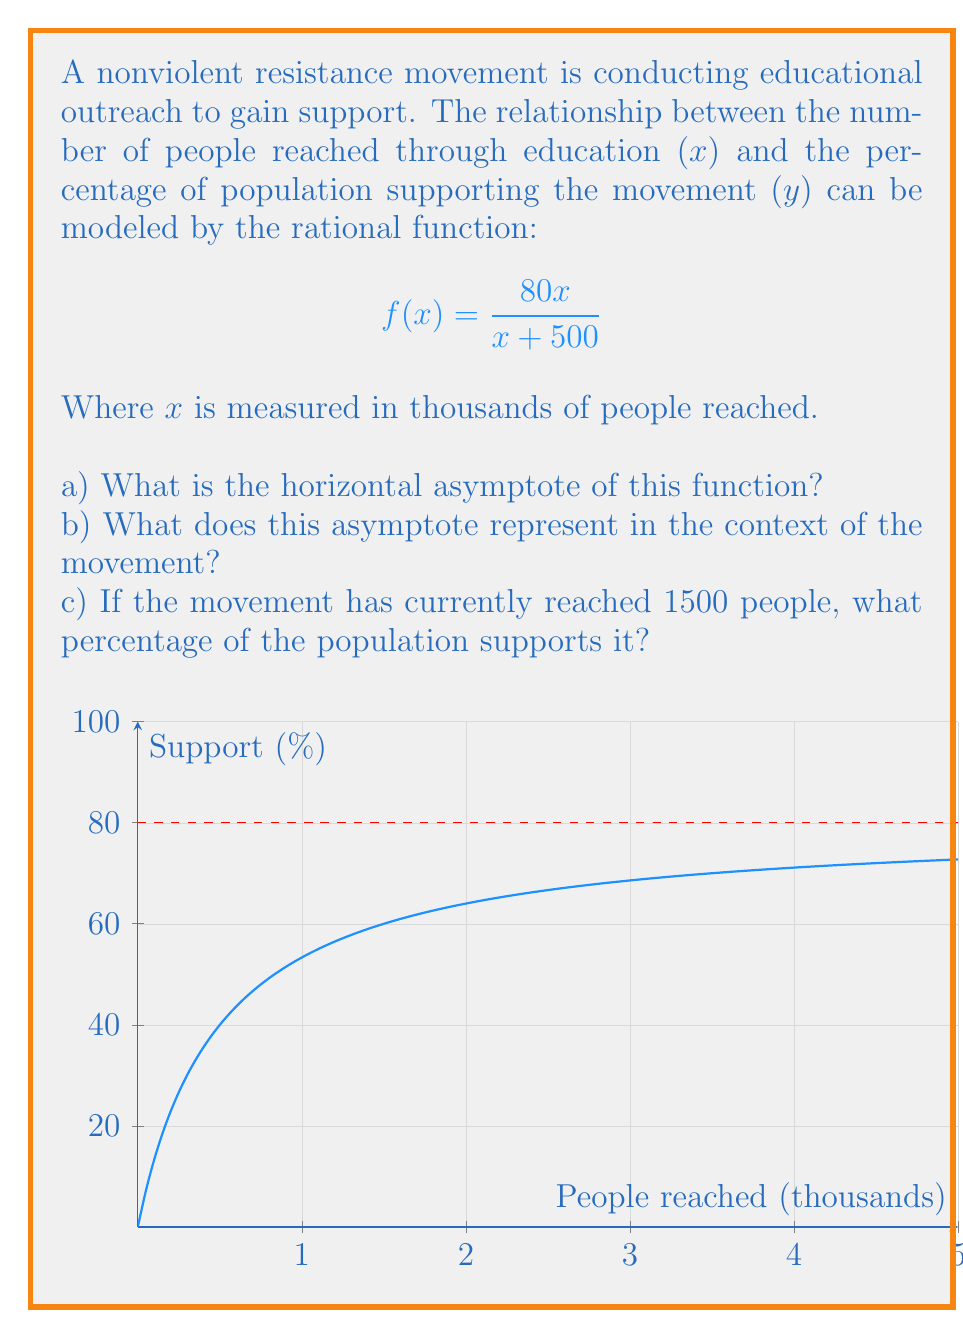Give your solution to this math problem. Let's approach this step-by-step:

a) To find the horizontal asymptote, we need to evaluate the limit of the function as x approaches infinity:

$$\lim_{x \to \infty} \frac{80x}{x + 500} = \lim_{x \to \infty} \frac{80}{1 + 500/x} = 80$$

The horizontal asymptote is y = 80.

b) In the context of the movement, this asymptote represents the maximum percentage of population support that can be achieved through educational outreach. No matter how many people are reached, the support will never exceed 80% of the population.

c) To find the support percentage when 1500 people are reached, we substitute x = 1.5 into the function:

$$f(1.5) = \frac{80(1.5)}{1.5 + 500} = \frac{120}{501.5} \approx 0.2393$$

Converting to a percentage: 0.2393 * 100 ≈ 23.93%

Therefore, when the movement has reached 1500 people, approximately 23.93% of the population supports it.
Answer: a) y = 80
b) Maximum achievable support (80%)
c) 23.93% 